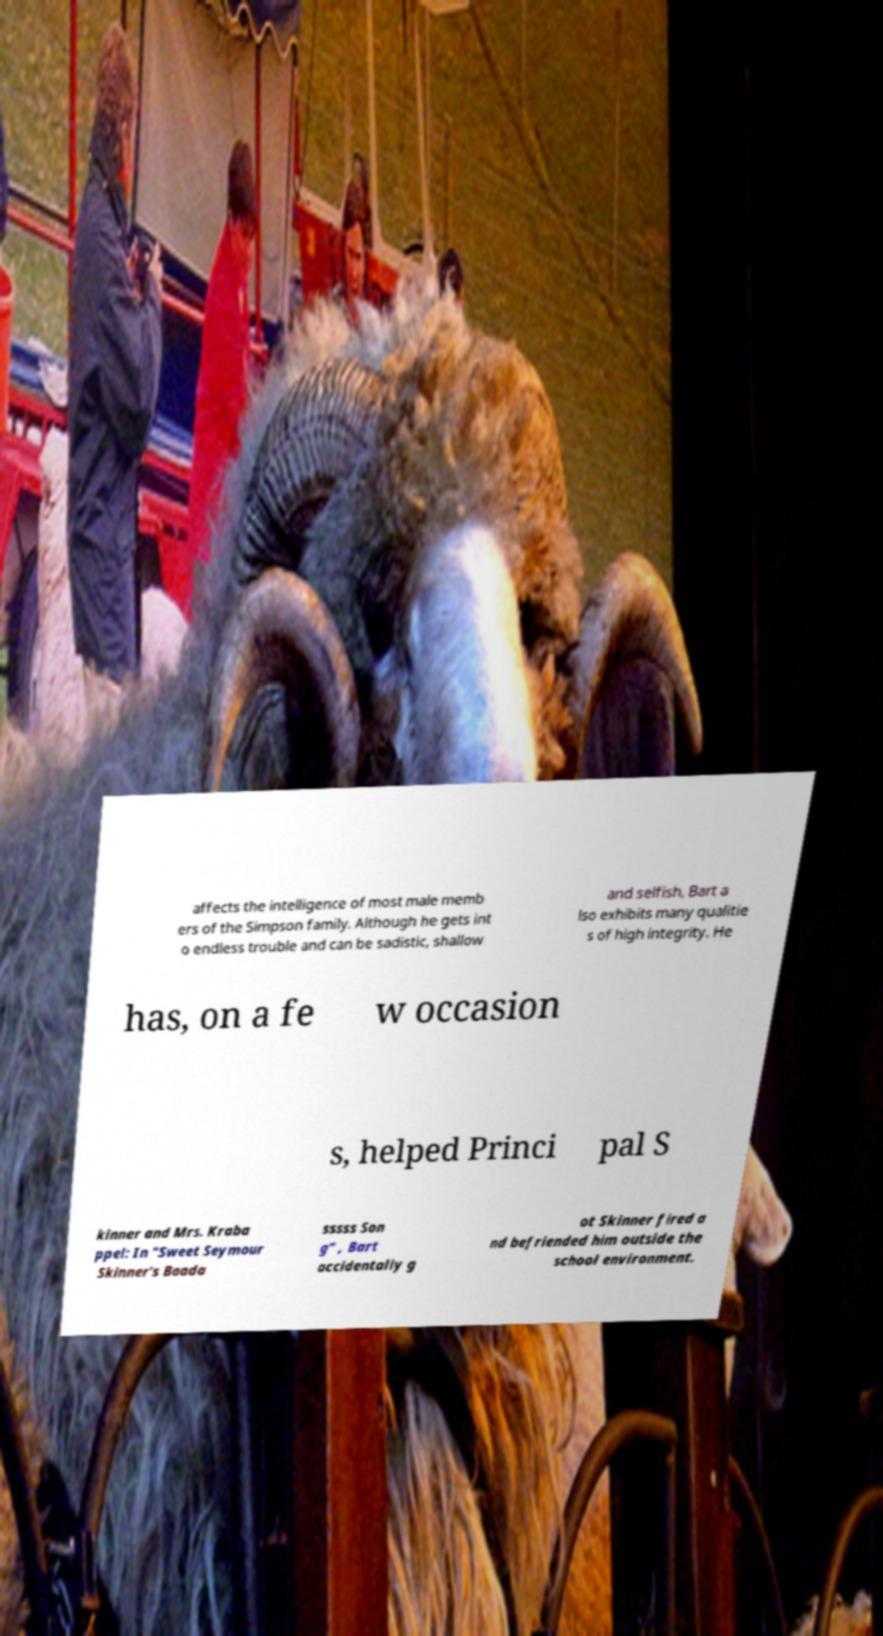Can you read and provide the text displayed in the image?This photo seems to have some interesting text. Can you extract and type it out for me? affects the intelligence of most male memb ers of the Simpson family. Although he gets int o endless trouble and can be sadistic, shallow and selfish, Bart a lso exhibits many qualitie s of high integrity. He has, on a fe w occasion s, helped Princi pal S kinner and Mrs. Kraba ppel: In "Sweet Seymour Skinner's Baada sssss Son g" , Bart accidentally g ot Skinner fired a nd befriended him outside the school environment. 